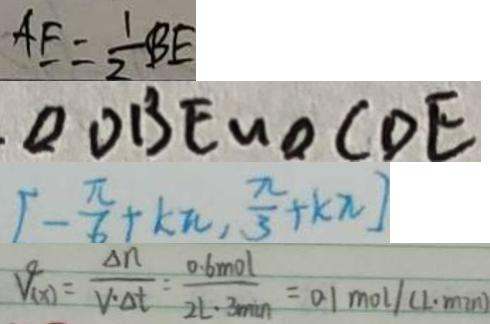Convert formula to latex. <formula><loc_0><loc_0><loc_500><loc_500>A E = \frac { 1 } { 2 } B E 
 \Delta D B E \sim \Delta C D E 
 [ - \frac { \pi } { 6 } + k \pi , \frac { \pi } { 3 } + k \pi ] 
 V _ { ( x ) } = \frac { \Delta n } { v \cdot \Delta t } = \frac { 0 . 6 m o l } { 2 L \cdot 3 \min } = 0 . 1 m o l ( L \cdot \min )</formula> 